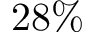Convert formula to latex. <formula><loc_0><loc_0><loc_500><loc_500>2 8 \%</formula> 